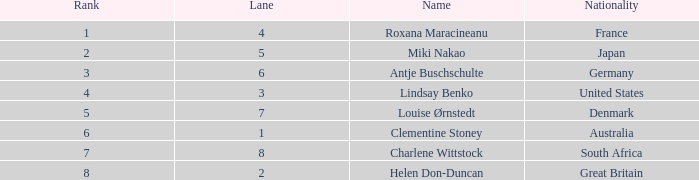95 is provided? South Africa. 